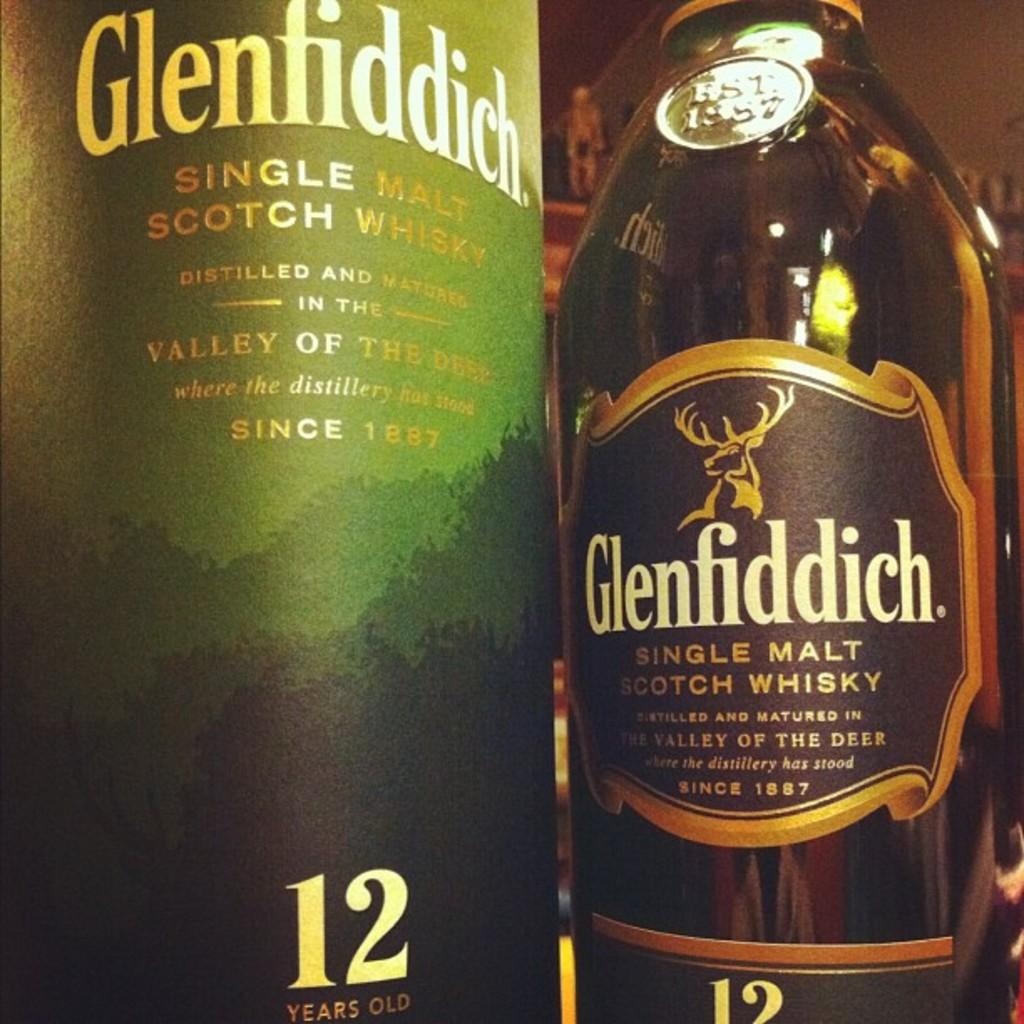<image>
Describe the image concisely. Two bottles of Glenfiddich, a single malt scotch whisky beverage. 